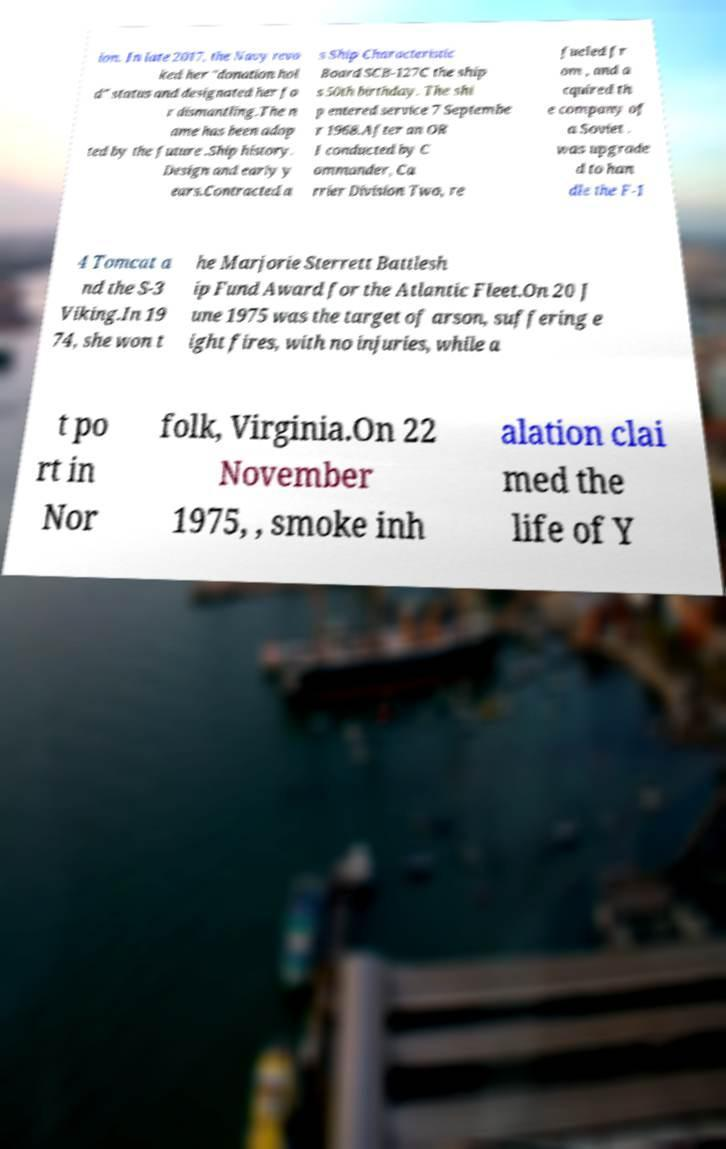Can you read and provide the text displayed in the image?This photo seems to have some interesting text. Can you extract and type it out for me? ion. In late 2017, the Navy revo ked her "donation hol d" status and designated her fo r dismantling.The n ame has been adop ted by the future .Ship history. Design and early y ears.Contracted a s Ship Characteristic Board SCB-127C the ship s 50th birthday. The shi p entered service 7 Septembe r 1968.After an OR I conducted by C ommander, Ca rrier Division Two, re fueled fr om , and a cquired th e company of a Soviet . was upgrade d to han dle the F-1 4 Tomcat a nd the S-3 Viking.In 19 74, she won t he Marjorie Sterrett Battlesh ip Fund Award for the Atlantic Fleet.On 20 J une 1975 was the target of arson, suffering e ight fires, with no injuries, while a t po rt in Nor folk, Virginia.On 22 November 1975, , smoke inh alation clai med the life of Y 